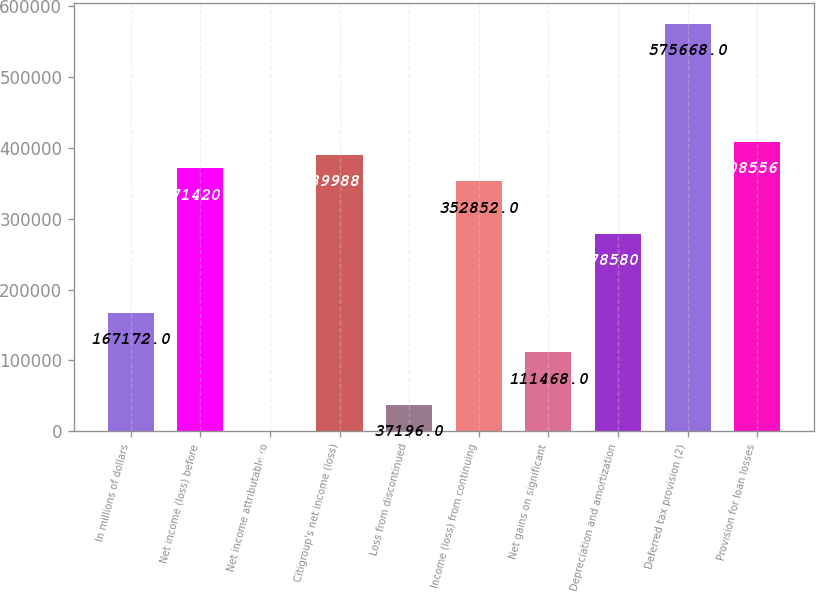<chart> <loc_0><loc_0><loc_500><loc_500><bar_chart><fcel>In millions of dollars<fcel>Net income (loss) before<fcel>Net income attributable to<fcel>Citigroup's net income (loss)<fcel>Loss from discontinued<fcel>Income (loss) from continuing<fcel>Net gains on significant<fcel>Depreciation and amortization<fcel>Deferred tax provision (2)<fcel>Provision for loan losses<nl><fcel>167172<fcel>371420<fcel>60<fcel>389988<fcel>37196<fcel>352852<fcel>111468<fcel>278580<fcel>575668<fcel>408556<nl></chart> 